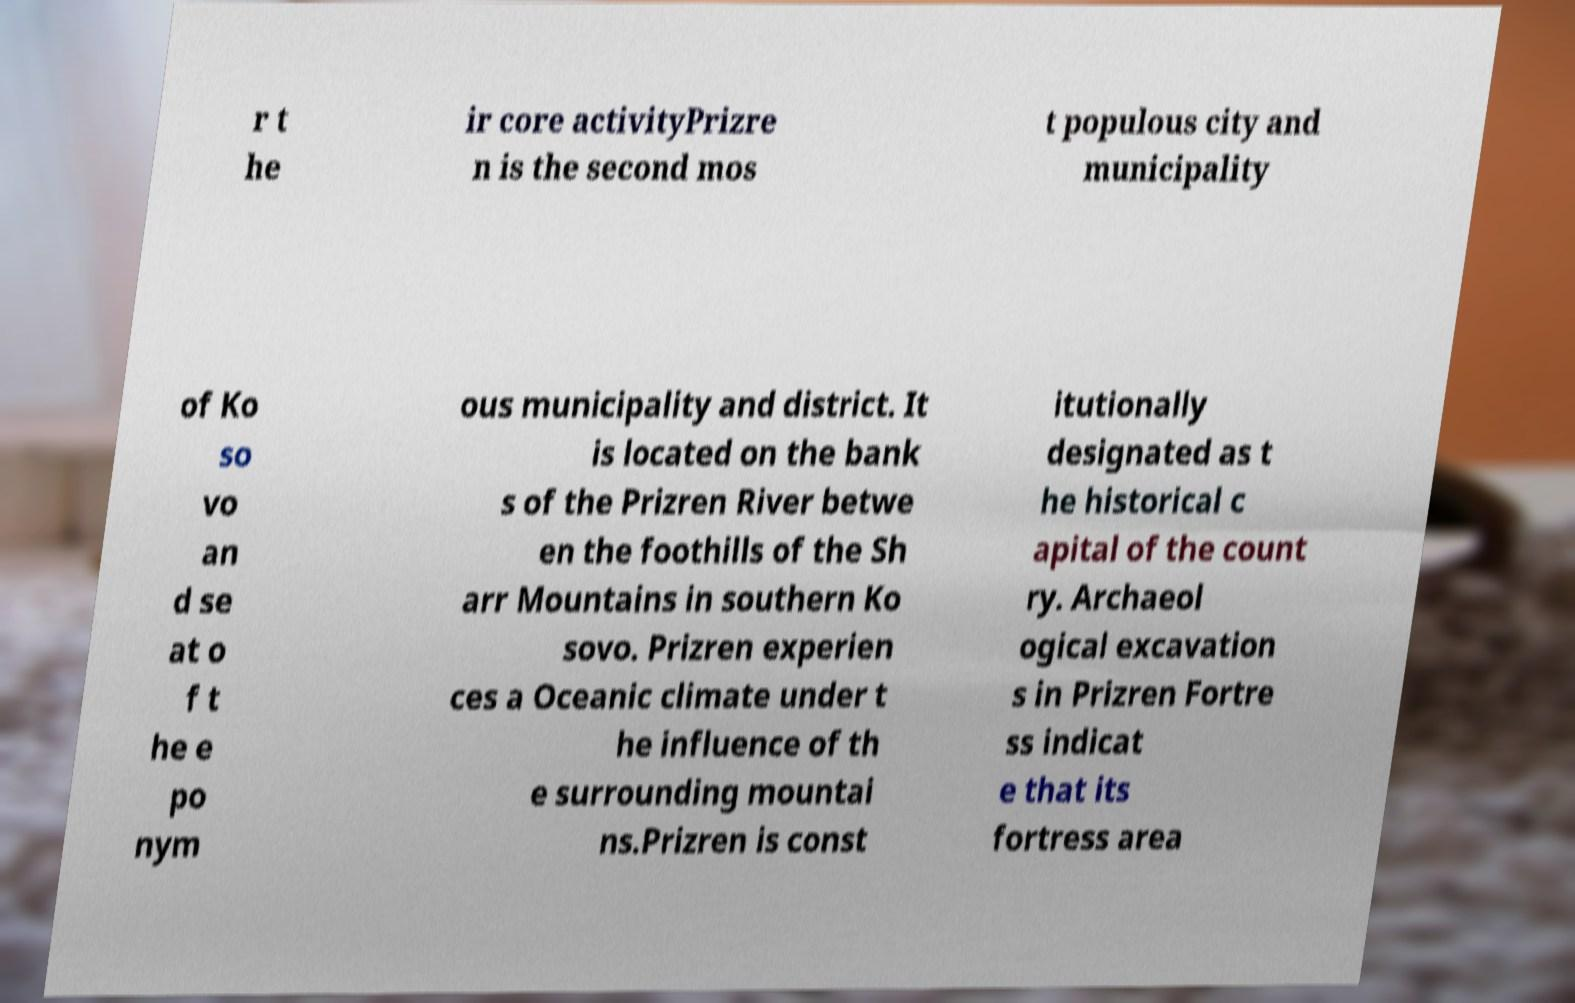Could you extract and type out the text from this image? r t he ir core activityPrizre n is the second mos t populous city and municipality of Ko so vo an d se at o f t he e po nym ous municipality and district. It is located on the bank s of the Prizren River betwe en the foothills of the Sh arr Mountains in southern Ko sovo. Prizren experien ces a Oceanic climate under t he influence of th e surrounding mountai ns.Prizren is const itutionally designated as t he historical c apital of the count ry. Archaeol ogical excavation s in Prizren Fortre ss indicat e that its fortress area 